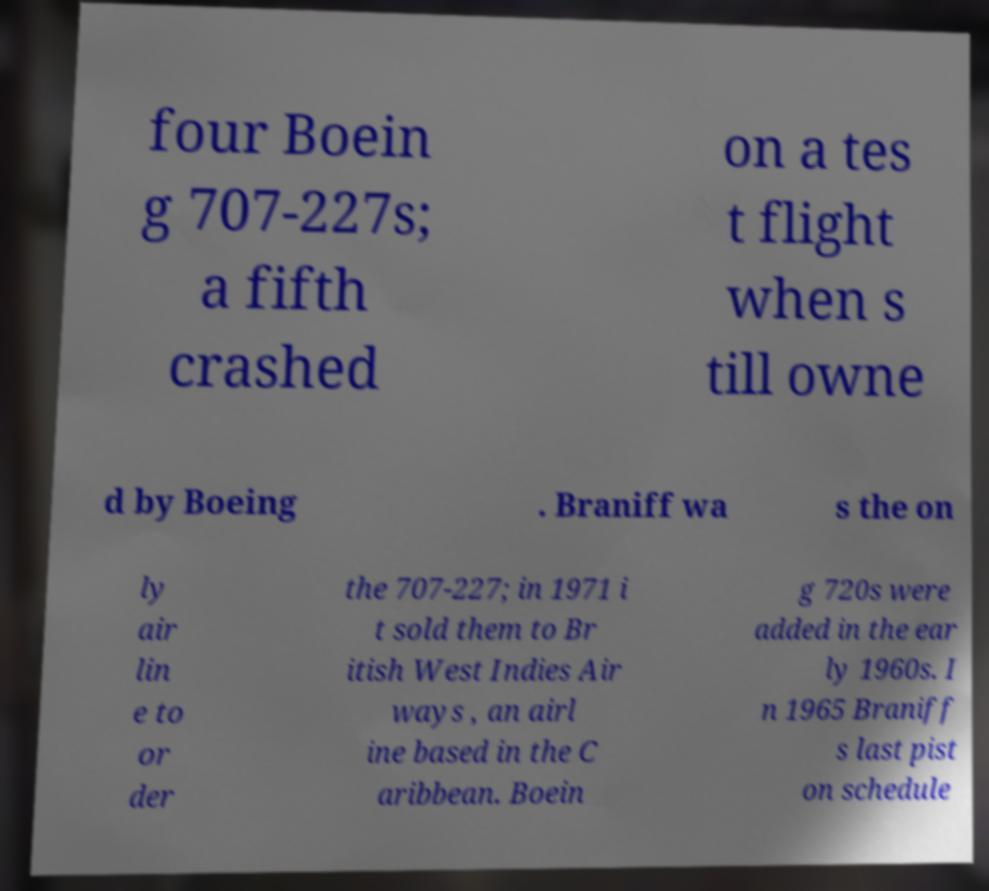Could you extract and type out the text from this image? four Boein g 707-227s; a fifth crashed on a tes t flight when s till owne d by Boeing . Braniff wa s the on ly air lin e to or der the 707-227; in 1971 i t sold them to Br itish West Indies Air ways , an airl ine based in the C aribbean. Boein g 720s were added in the ear ly 1960s. I n 1965 Braniff s last pist on schedule 